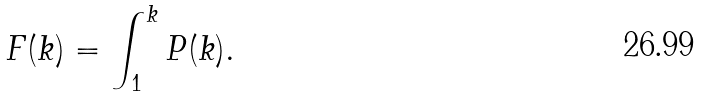Convert formula to latex. <formula><loc_0><loc_0><loc_500><loc_500>F ( k ) = \int _ { 1 } ^ { k } P ( k ) .</formula> 